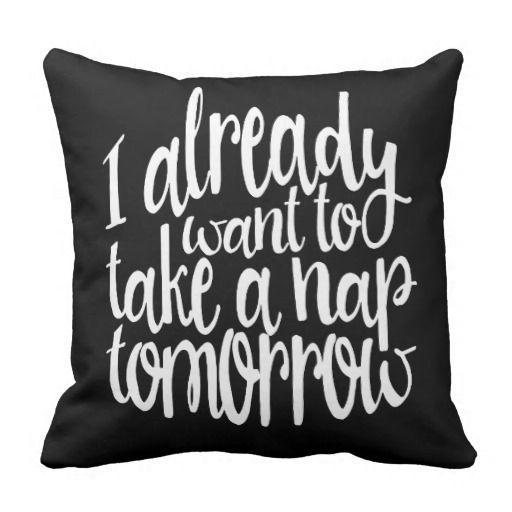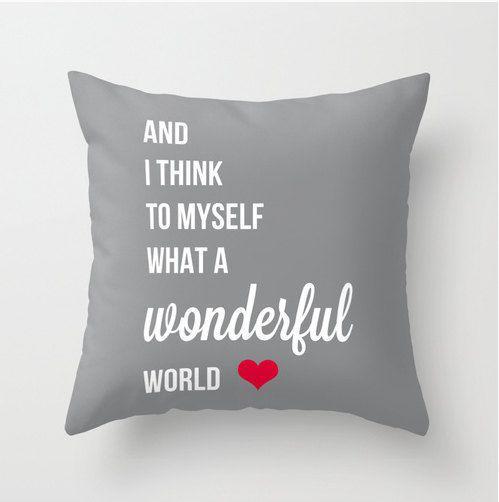The first image is the image on the left, the second image is the image on the right. Assess this claim about the two images: "IN at least one image there is a light gray pillow with at least five lines of white writing.". Correct or not? Answer yes or no. Yes. The first image is the image on the left, the second image is the image on the right. Examine the images to the left and right. Is the description "All pillows feature text as their primary decoration, and at least one pillow is dark black with bold white lettering." accurate? Answer yes or no. Yes. 